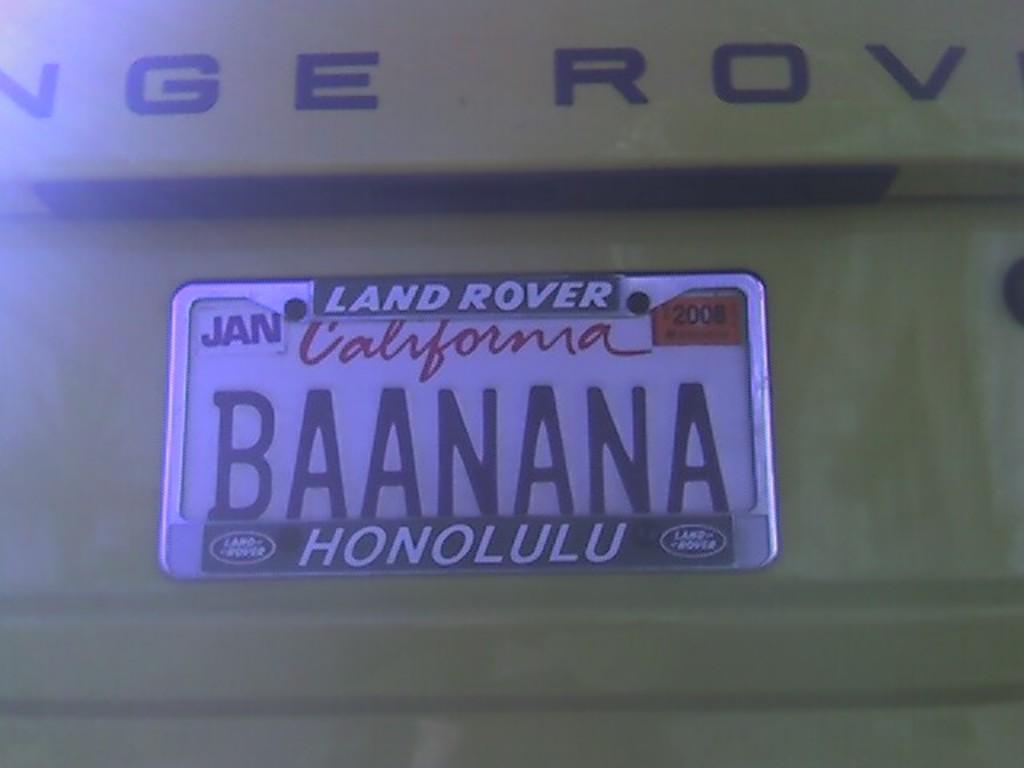Provide a one-sentence caption for the provided image. A California license plate with the word BAANANA printed on it. 